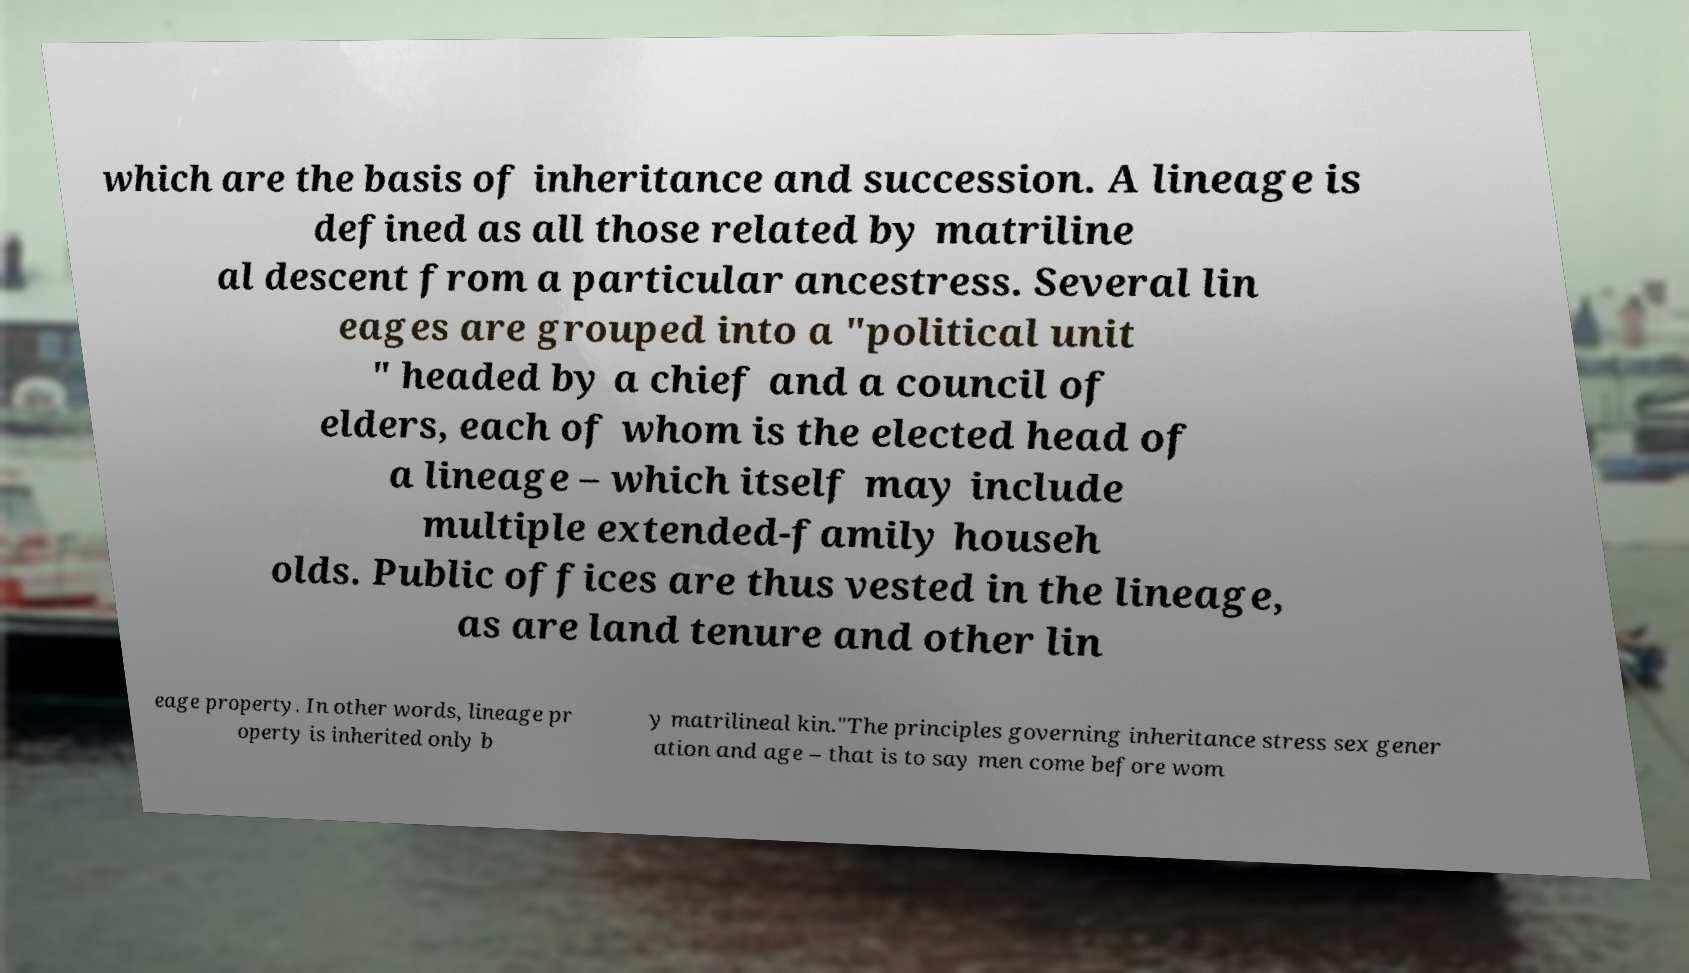For documentation purposes, I need the text within this image transcribed. Could you provide that? which are the basis of inheritance and succession. A lineage is defined as all those related by matriline al descent from a particular ancestress. Several lin eages are grouped into a "political unit " headed by a chief and a council of elders, each of whom is the elected head of a lineage – which itself may include multiple extended-family househ olds. Public offices are thus vested in the lineage, as are land tenure and other lin eage property. In other words, lineage pr operty is inherited only b y matrilineal kin."The principles governing inheritance stress sex gener ation and age – that is to say men come before wom 